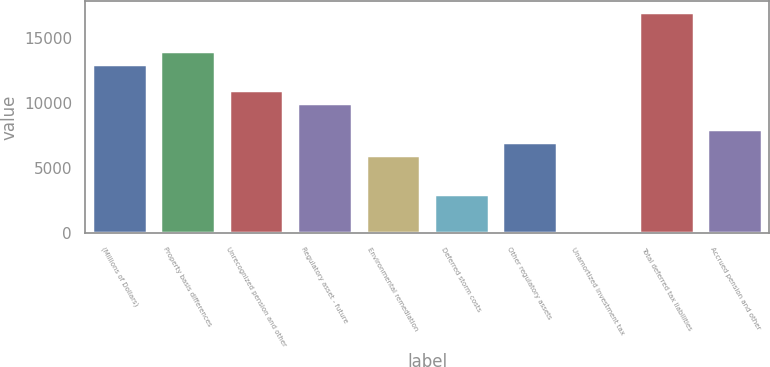Convert chart to OTSL. <chart><loc_0><loc_0><loc_500><loc_500><bar_chart><fcel>(Millions of Dollars)<fcel>Property basis differences<fcel>Unrecognized pension and other<fcel>Regulatory asset - future<fcel>Environmental remediation<fcel>Deferred storm costs<fcel>Other regulatory assets<fcel>Unamortized investment tax<fcel>Total deferred tax liabilities<fcel>Accrued pension and other<nl><fcel>13010.5<fcel>14008<fcel>11015.5<fcel>10018<fcel>6028<fcel>3035.5<fcel>7025.5<fcel>43<fcel>17000.5<fcel>8023<nl></chart> 